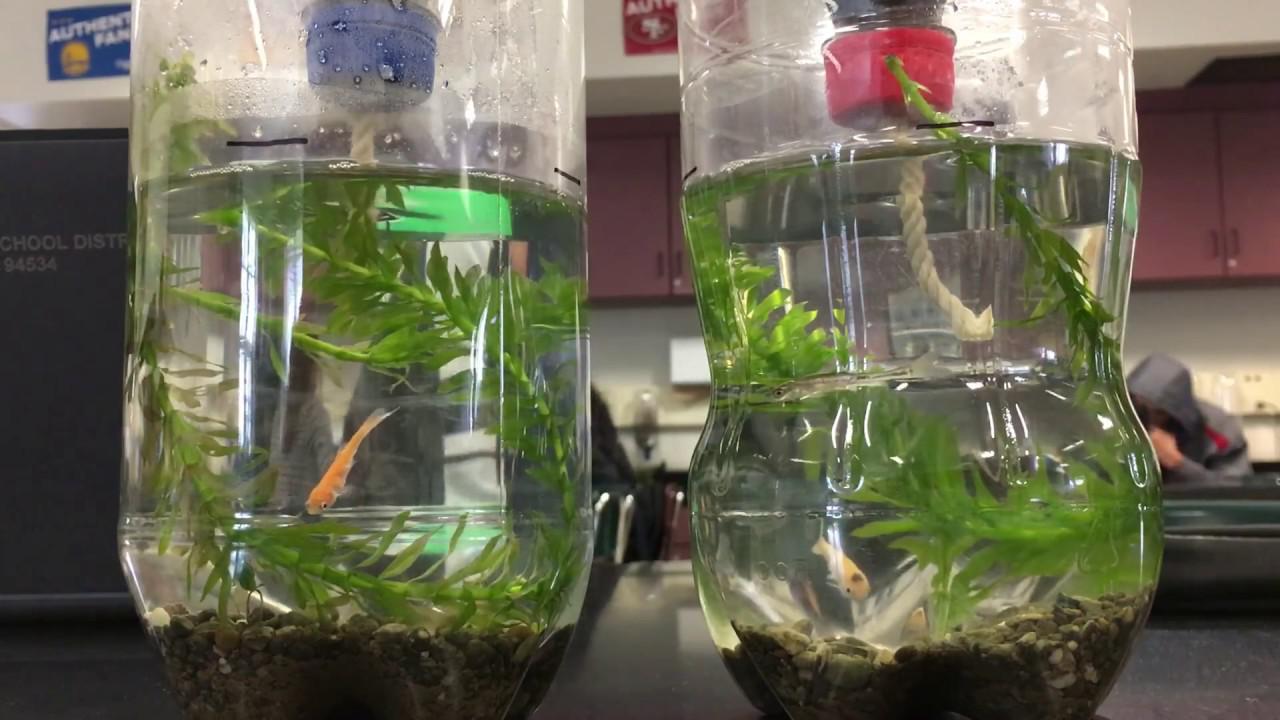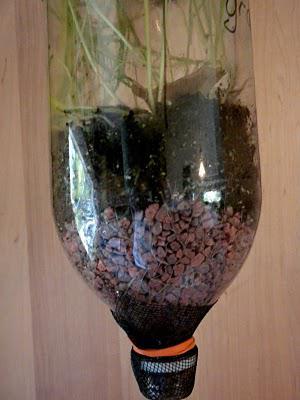The first image is the image on the left, the second image is the image on the right. Assess this claim about the two images: "The combined images contain four bottle displays with green plants in them.". Correct or not? Answer yes or no. No. The first image is the image on the left, the second image is the image on the right. Examine the images to the left and right. Is the description "There are more bottles in the image on the left." accurate? Answer yes or no. Yes. 